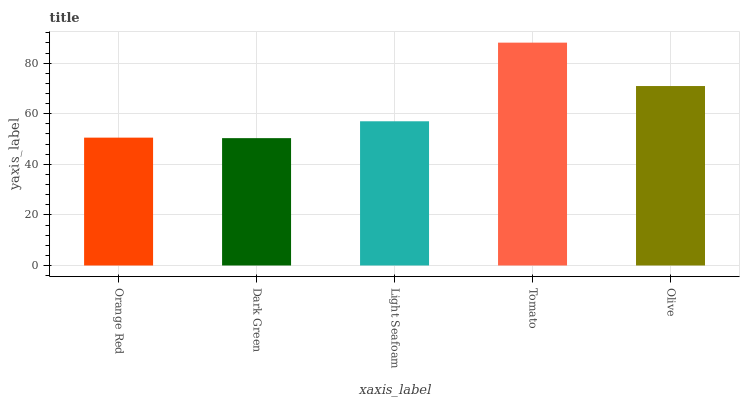Is Dark Green the minimum?
Answer yes or no. Yes. Is Tomato the maximum?
Answer yes or no. Yes. Is Light Seafoam the minimum?
Answer yes or no. No. Is Light Seafoam the maximum?
Answer yes or no. No. Is Light Seafoam greater than Dark Green?
Answer yes or no. Yes. Is Dark Green less than Light Seafoam?
Answer yes or no. Yes. Is Dark Green greater than Light Seafoam?
Answer yes or no. No. Is Light Seafoam less than Dark Green?
Answer yes or no. No. Is Light Seafoam the high median?
Answer yes or no. Yes. Is Light Seafoam the low median?
Answer yes or no. Yes. Is Dark Green the high median?
Answer yes or no. No. Is Olive the low median?
Answer yes or no. No. 